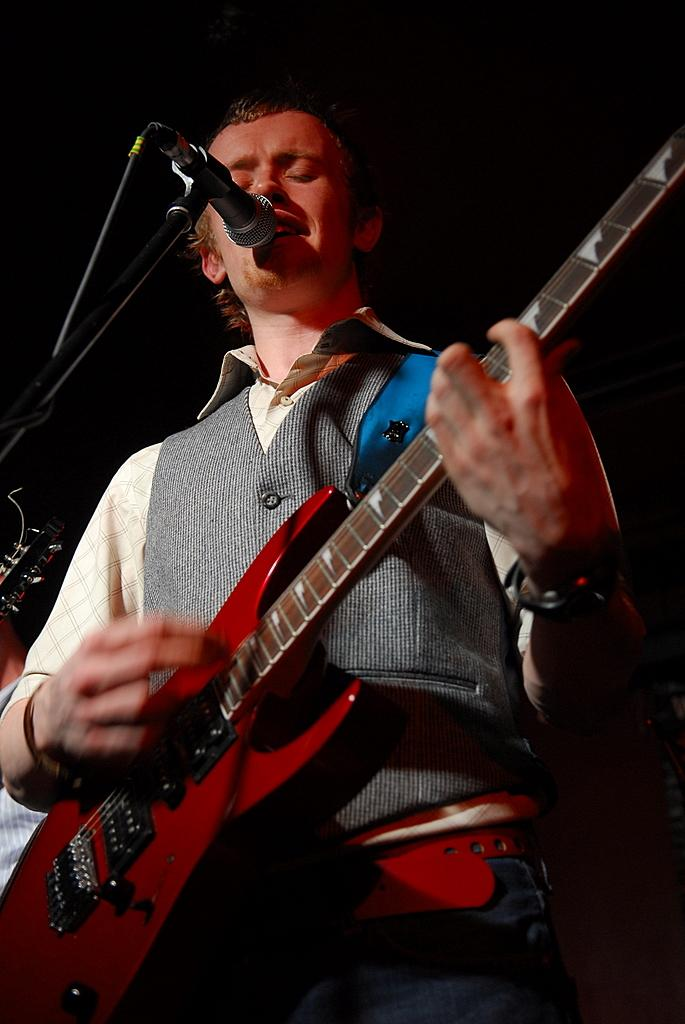Who is the main subject in the image? There is a man in the image. What is the man holding in the image? The man is holding a guitar. What is the man doing with the guitar? The man is playing the guitar. What other activity is the man engaged in? The man is singing. What object is present in the image that might be used for amplifying the man's voice? There is a microphone in the image. What type of whip is the man using to play the guitar in the image? There is no whip present in the image; the man is playing the guitar with his hands. 